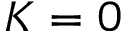Convert formula to latex. <formula><loc_0><loc_0><loc_500><loc_500>K = 0</formula> 